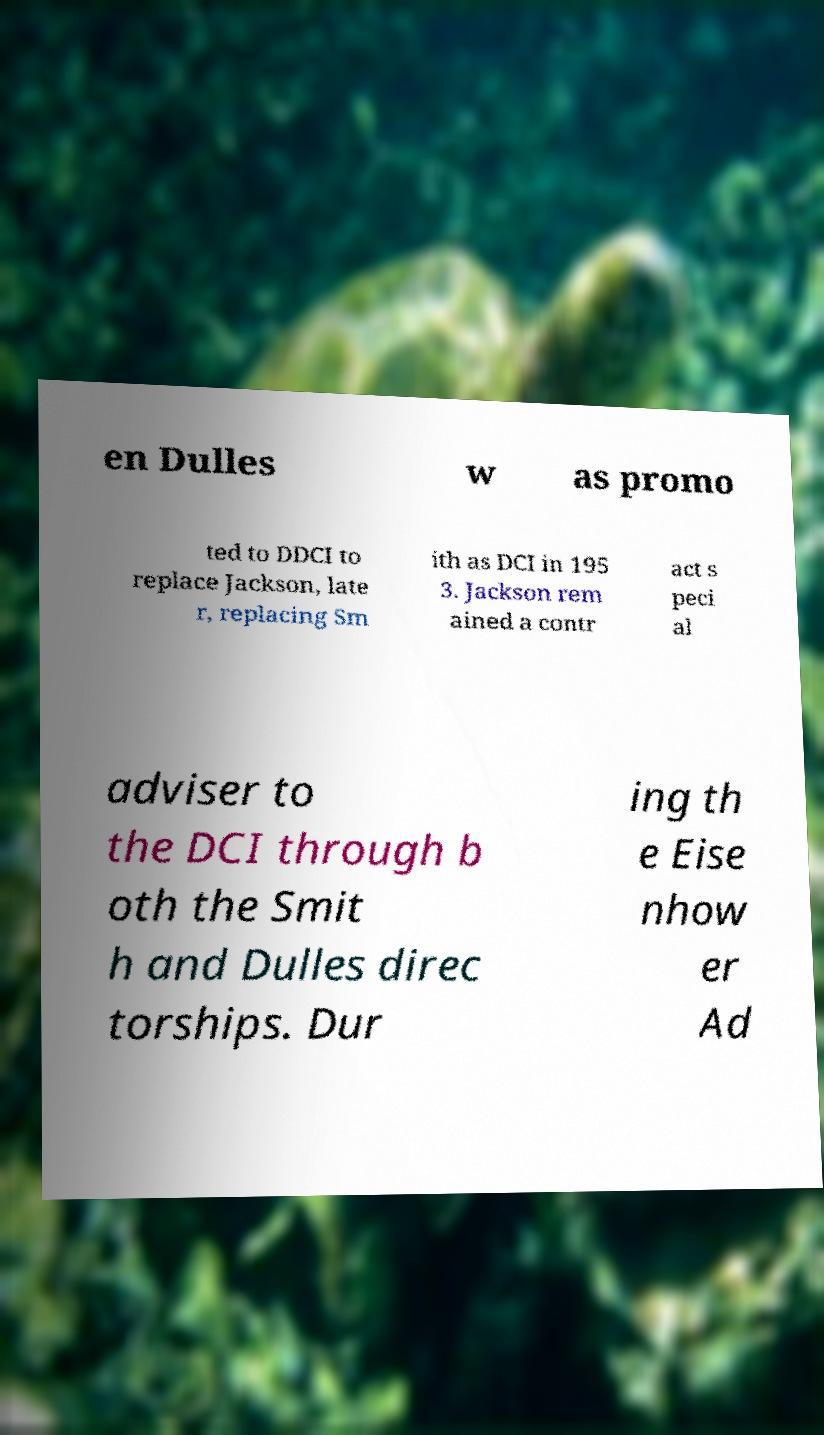Can you read and provide the text displayed in the image?This photo seems to have some interesting text. Can you extract and type it out for me? en Dulles w as promo ted to DDCI to replace Jackson, late r, replacing Sm ith as DCI in 195 3. Jackson rem ained a contr act s peci al adviser to the DCI through b oth the Smit h and Dulles direc torships. Dur ing th e Eise nhow er Ad 